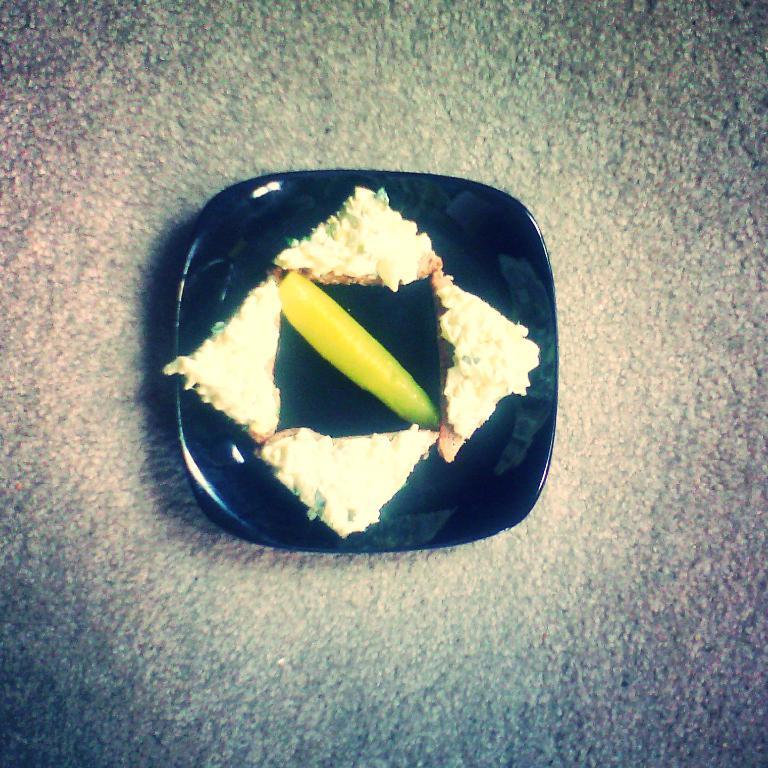How would you summarize this image in a sentence or two? In this image we can see some food in a plate which is placed on the surface. 